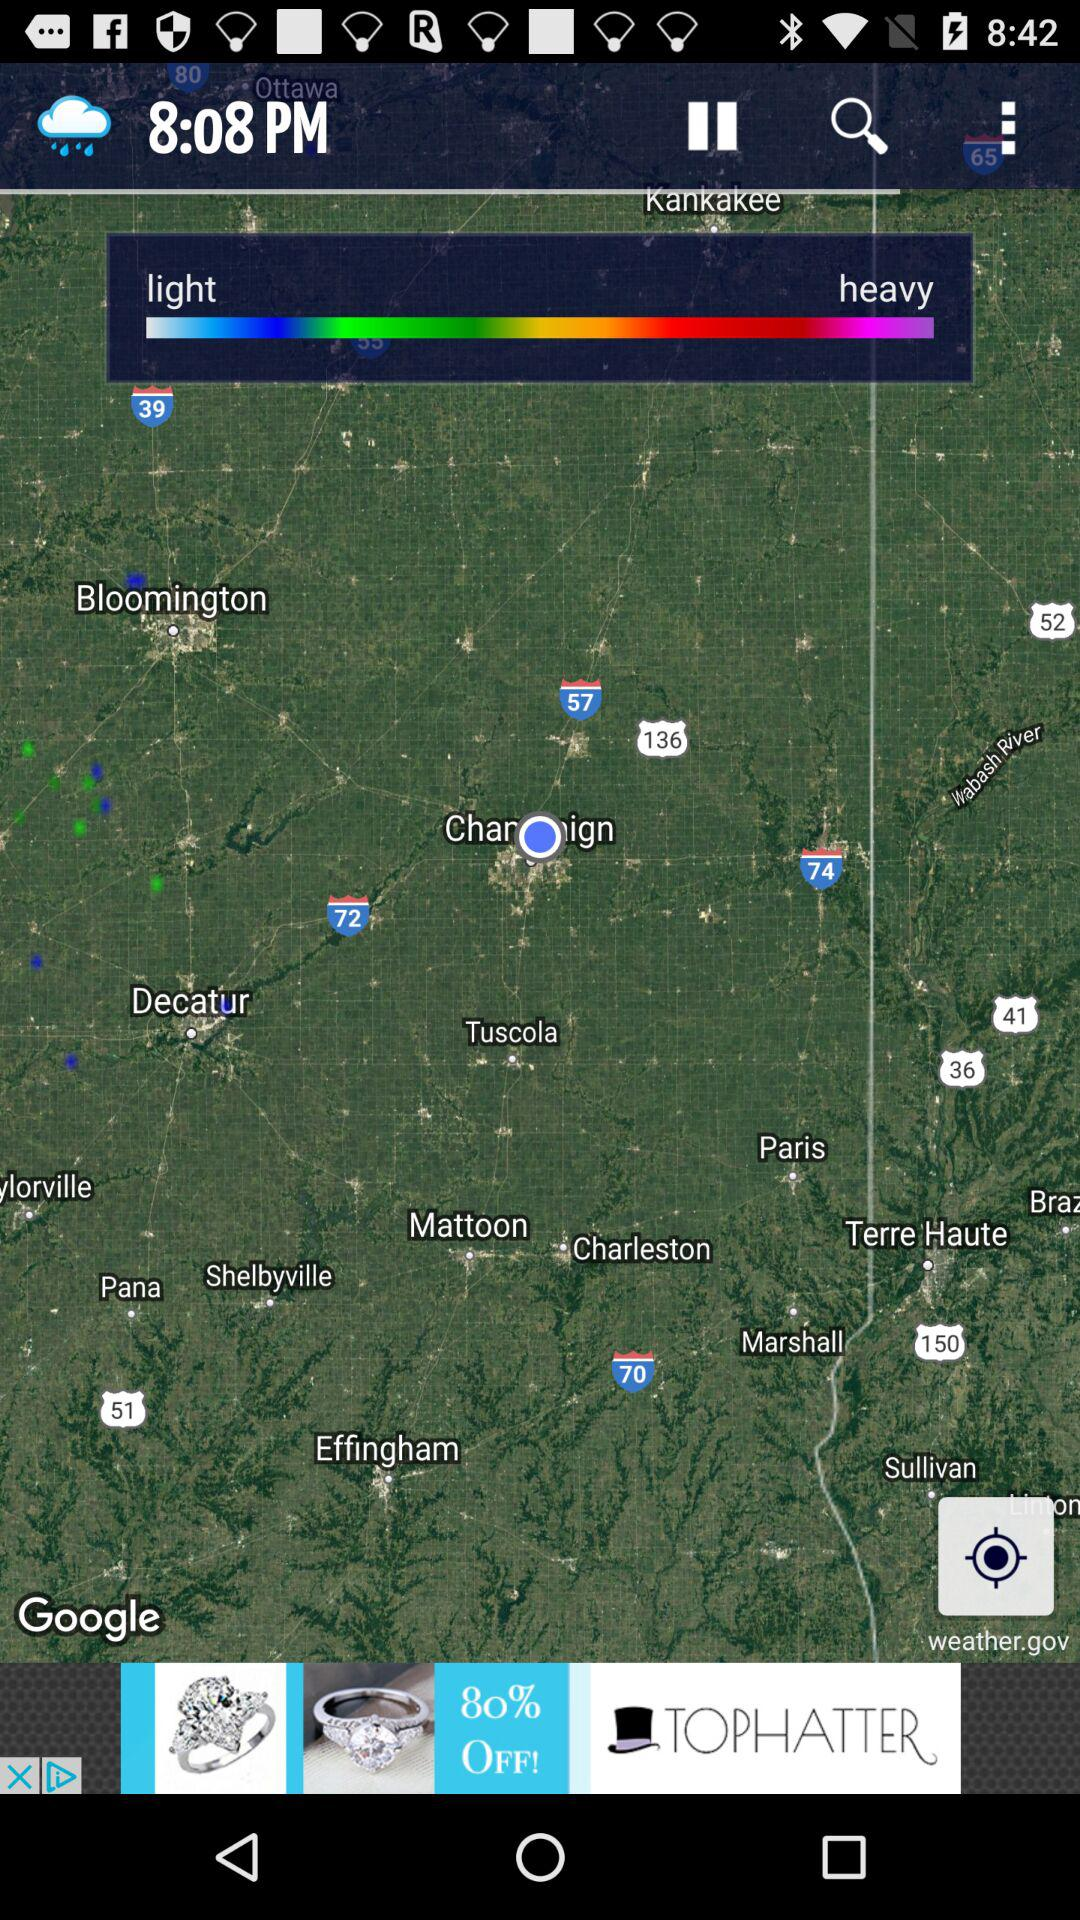What time is shown on the screen? The time is 8:08 PM. 